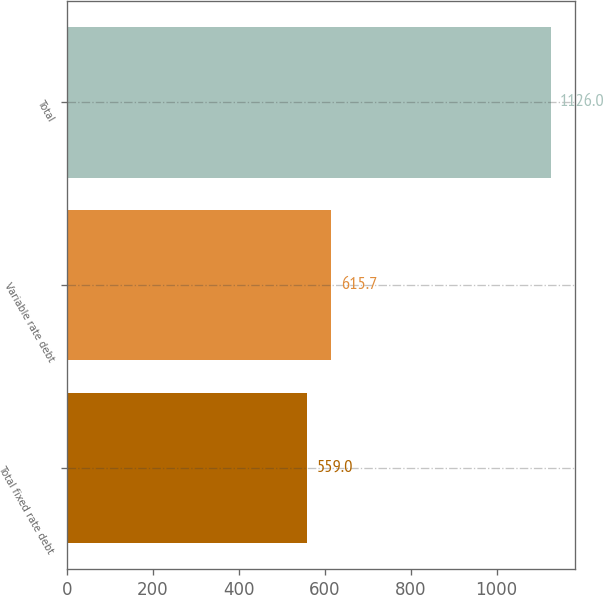<chart> <loc_0><loc_0><loc_500><loc_500><bar_chart><fcel>Total fixed rate debt<fcel>Variable rate debt<fcel>Total<nl><fcel>559<fcel>615.7<fcel>1126<nl></chart> 